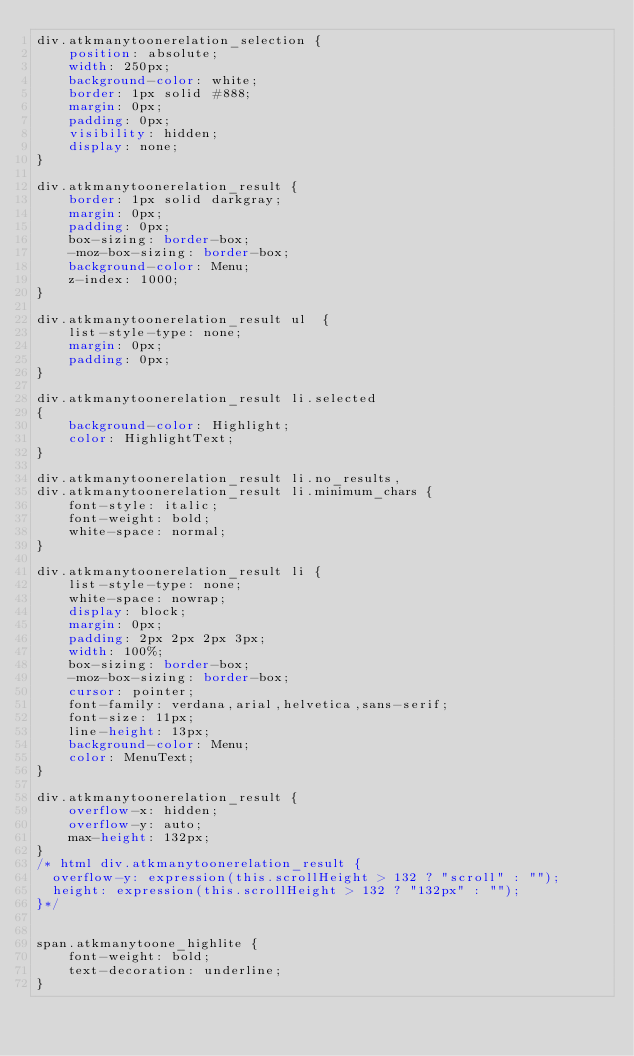<code> <loc_0><loc_0><loc_500><loc_500><_CSS_>div.atkmanytoonerelation_selection {
    position: absolute;
    width: 250px;
    background-color: white;
    border: 1px solid #888;
    margin: 0px;
    padding: 0px;
    visibility: hidden;
    display: none;
}

div.atkmanytoonerelation_result {
    border: 1px solid darkgray;
    margin: 0px;
    padding: 0px;
    box-sizing: border-box;
    -moz-box-sizing: border-box;
    background-color: Menu;
    z-index: 1000;
}

div.atkmanytoonerelation_result ul  {
    list-style-type: none;
    margin: 0px;
    padding: 0px;
}

div.atkmanytoonerelation_result li.selected
{
    background-color: Highlight;
    color: HighlightText;
}

div.atkmanytoonerelation_result li.no_results,
div.atkmanytoonerelation_result li.minimum_chars {
    font-style: italic;
    font-weight: bold;
    white-space: normal;
}

div.atkmanytoonerelation_result li {
    list-style-type: none;
    white-space: nowrap;
    display: block;
    margin: 0px;
    padding: 2px 2px 2px 3px;
    width: 100%;
    box-sizing: border-box;
    -moz-box-sizing: border-box;
    cursor: pointer;
    font-family: verdana,arial,helvetica,sans-serif;
    font-size: 11px;
    line-height: 13px;
    background-color: Menu;
    color: MenuText;
}

div.atkmanytoonerelation_result {
    overflow-x: hidden;
    overflow-y: auto;
    max-height: 132px;
}
/* html div.atkmanytoonerelation_result {
  overflow-y: expression(this.scrollHeight > 132 ? "scroll" : "");
  height: expression(this.scrollHeight > 132 ? "132px" : "");
}*/


span.atkmanytoone_highlite {
    font-weight: bold;
    text-decoration: underline;
}
</code> 